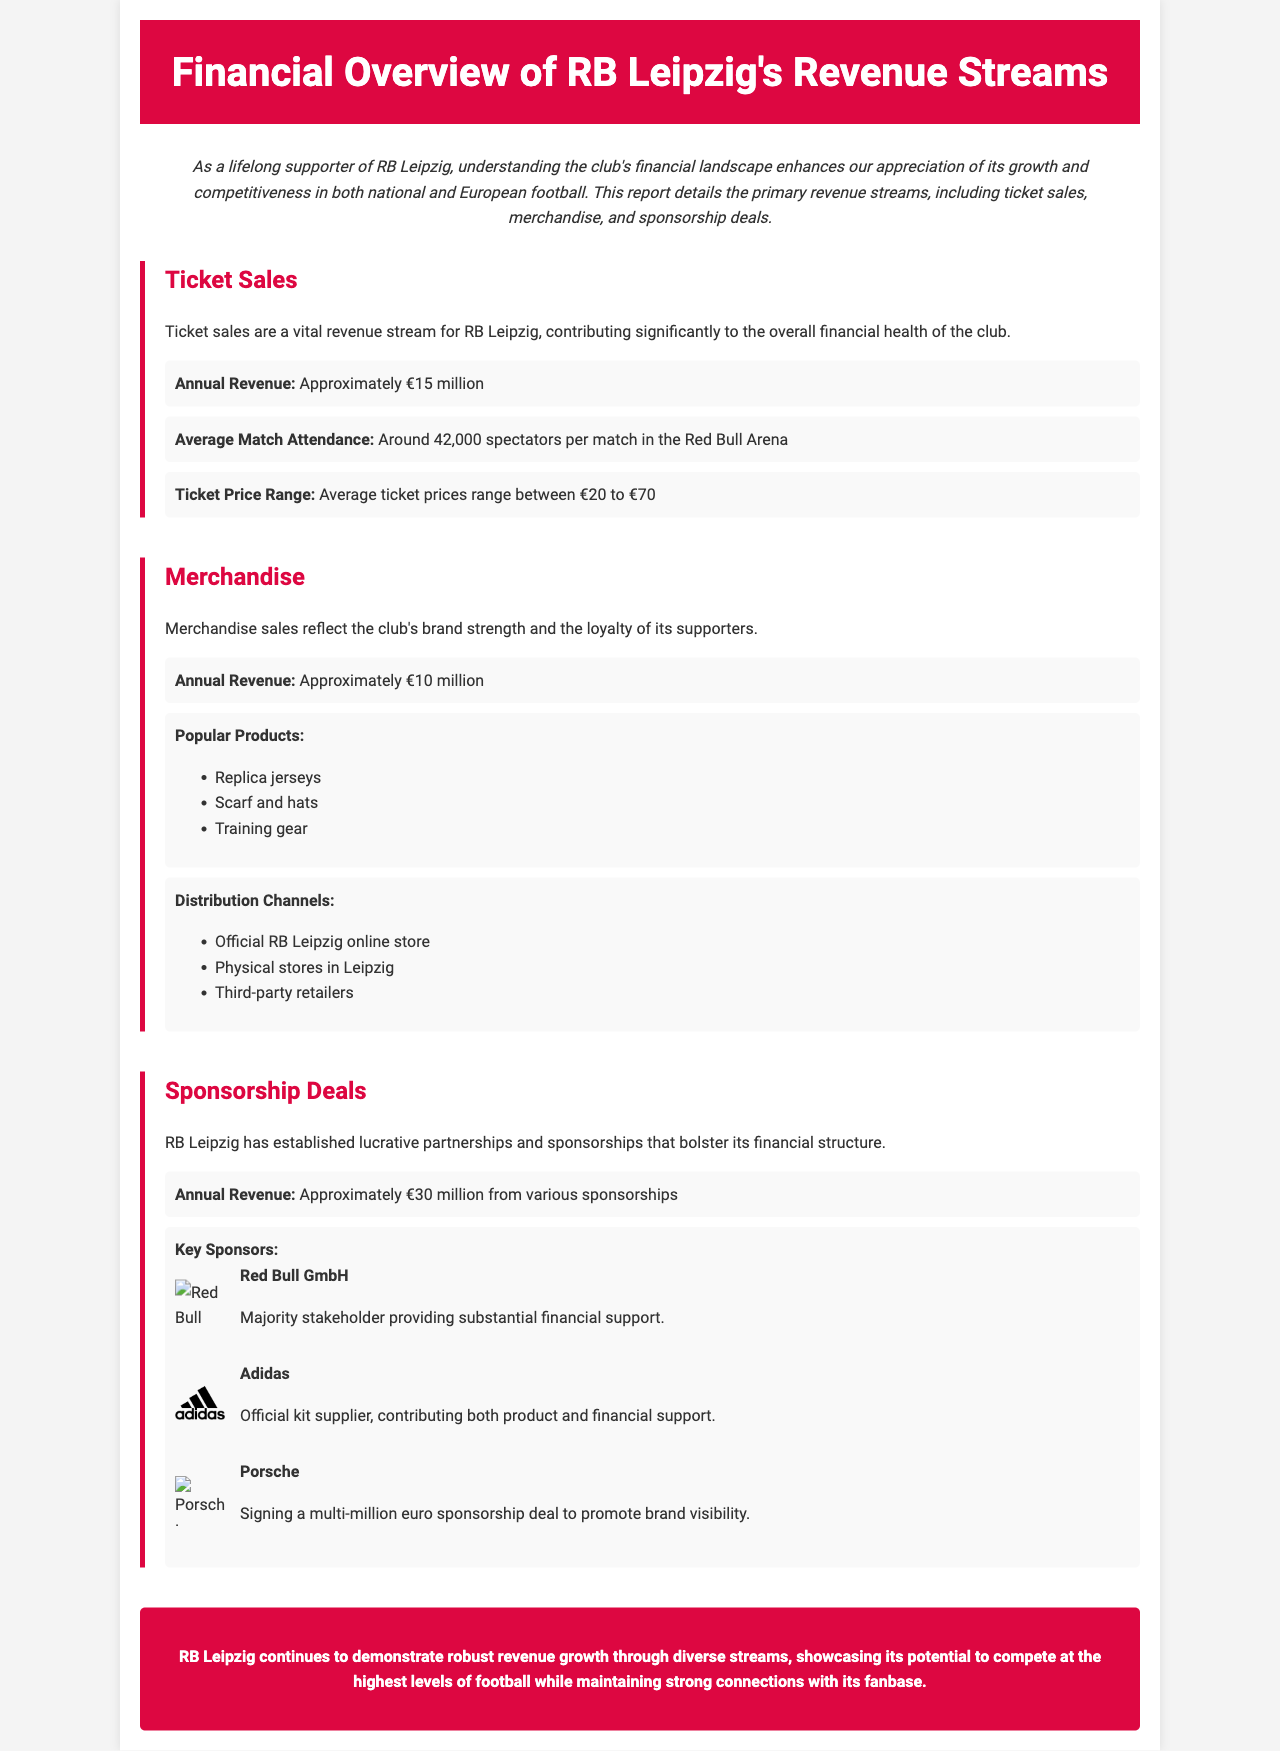What is the annual revenue from ticket sales? The document specifies that ticket sales contribute approximately 15 million euros annually.
Answer: Approximately €15 million What is the average match attendance at the Red Bull Arena? The report states that the average match attendance is around 42,000 spectators per match.
Answer: Around 42,000 spectators What is the ticket price range for RB Leipzig matches? It mentions that average ticket prices range between 20 to 70 euros.
Answer: €20 to €70 What is the annual revenue from merchandise sales? The document notes that merchandise sales generate approximately 10 million euros annually.
Answer: Approximately €10 million What are the popular merchandise products listed? The report lists replica jerseys, scarf and hats, and training gear as popular merchandise products.
Answer: Replica jerseys, scarf and hats, training gear How much annual revenue do sponsorship deals contribute? The document indicates that sponsorships provide approximately 30 million euros in annual revenue.
Answer: Approximately €30 million Who is the majority stakeholder of RB Leipzig? It is stated that Red Bull GmbH is the majority stakeholder providing substantial financial support.
Answer: Red Bull GmbH Which company is the official kit supplier? The document specifies that Adidas is the official kit supplier for RB Leipzig.
Answer: Adidas What is the primary goal of the financial overview report? The report aims at enhancing the understanding of RB Leipzig's financial landscape for supporters.
Answer: Understanding the financial landscape 